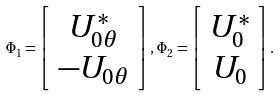<formula> <loc_0><loc_0><loc_500><loc_500>\Phi _ { 1 } = \left [ \begin{array} { c } U _ { 0 \theta } ^ { * } \\ - U _ { 0 \theta } \end{array} \right ] , \, \Phi _ { 2 } = \left [ \begin{array} { c } U _ { 0 } ^ { * } \\ U _ { 0 } \end{array} \right ] .</formula> 